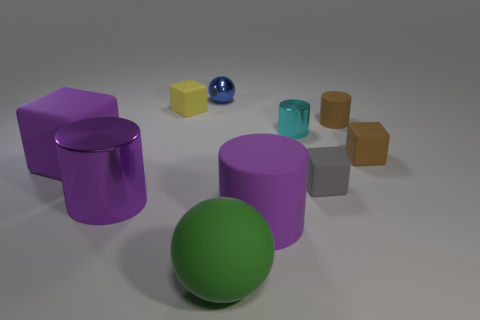Subtract all gray rubber cubes. How many cubes are left? 3 Subtract all brown cubes. How many cubes are left? 3 Add 3 cyan metal cubes. How many cyan metal cubes exist? 3 Subtract 0 yellow cylinders. How many objects are left? 10 Subtract all balls. How many objects are left? 8 Subtract 2 spheres. How many spheres are left? 0 Subtract all yellow cylinders. Subtract all purple spheres. How many cylinders are left? 4 Subtract all blue cylinders. How many brown cubes are left? 1 Subtract all small cyan cylinders. Subtract all tiny cyan objects. How many objects are left? 8 Add 1 small gray rubber cubes. How many small gray rubber cubes are left? 2 